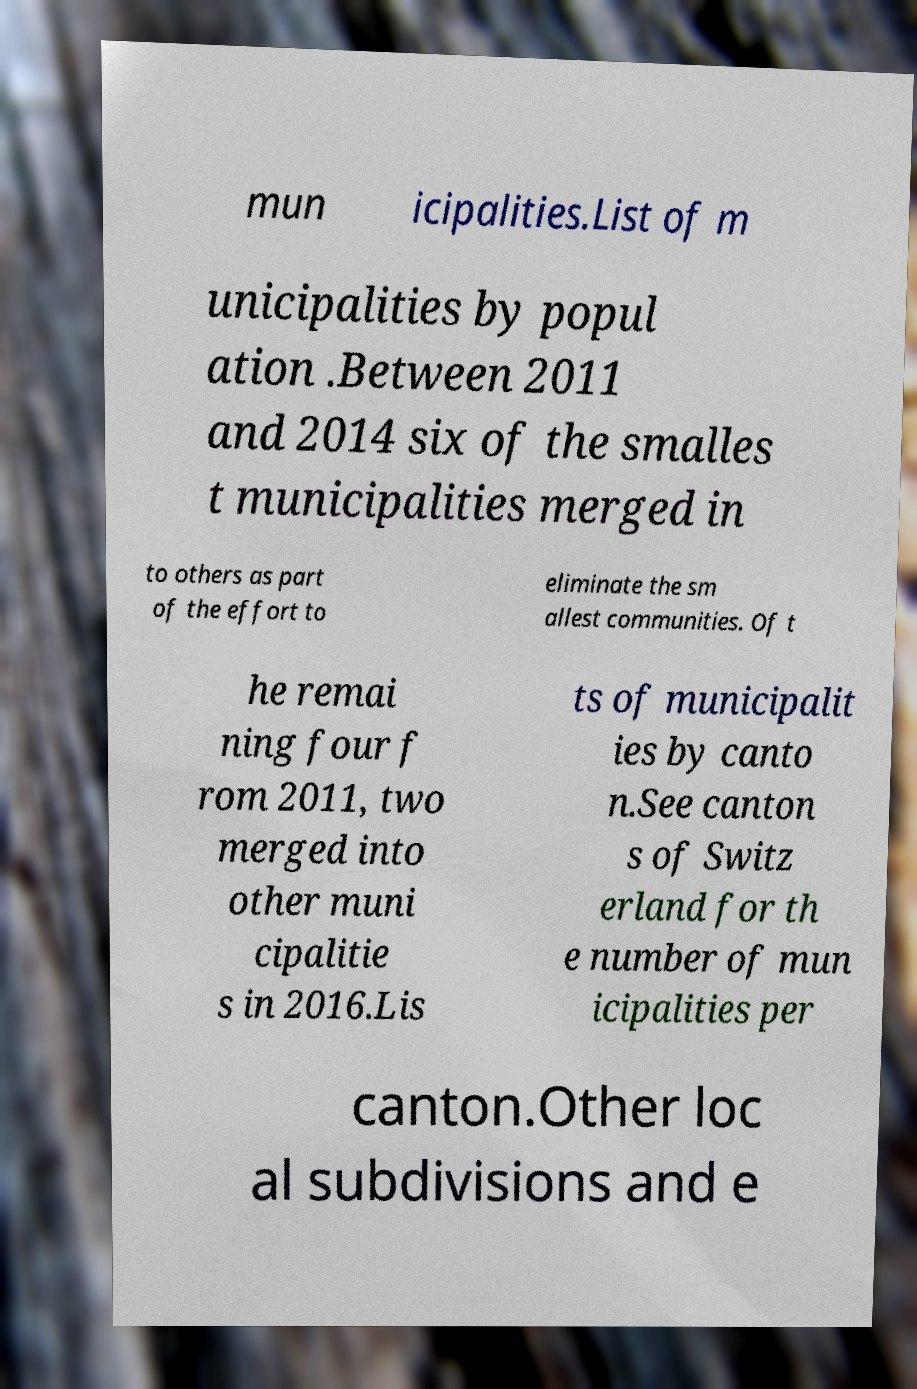Can you read and provide the text displayed in the image?This photo seems to have some interesting text. Can you extract and type it out for me? mun icipalities.List of m unicipalities by popul ation .Between 2011 and 2014 six of the smalles t municipalities merged in to others as part of the effort to eliminate the sm allest communities. Of t he remai ning four f rom 2011, two merged into other muni cipalitie s in 2016.Lis ts of municipalit ies by canto n.See canton s of Switz erland for th e number of mun icipalities per canton.Other loc al subdivisions and e 